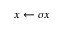Convert formula to latex. <formula><loc_0><loc_0><loc_500><loc_500>x \gets \sigma x</formula> 